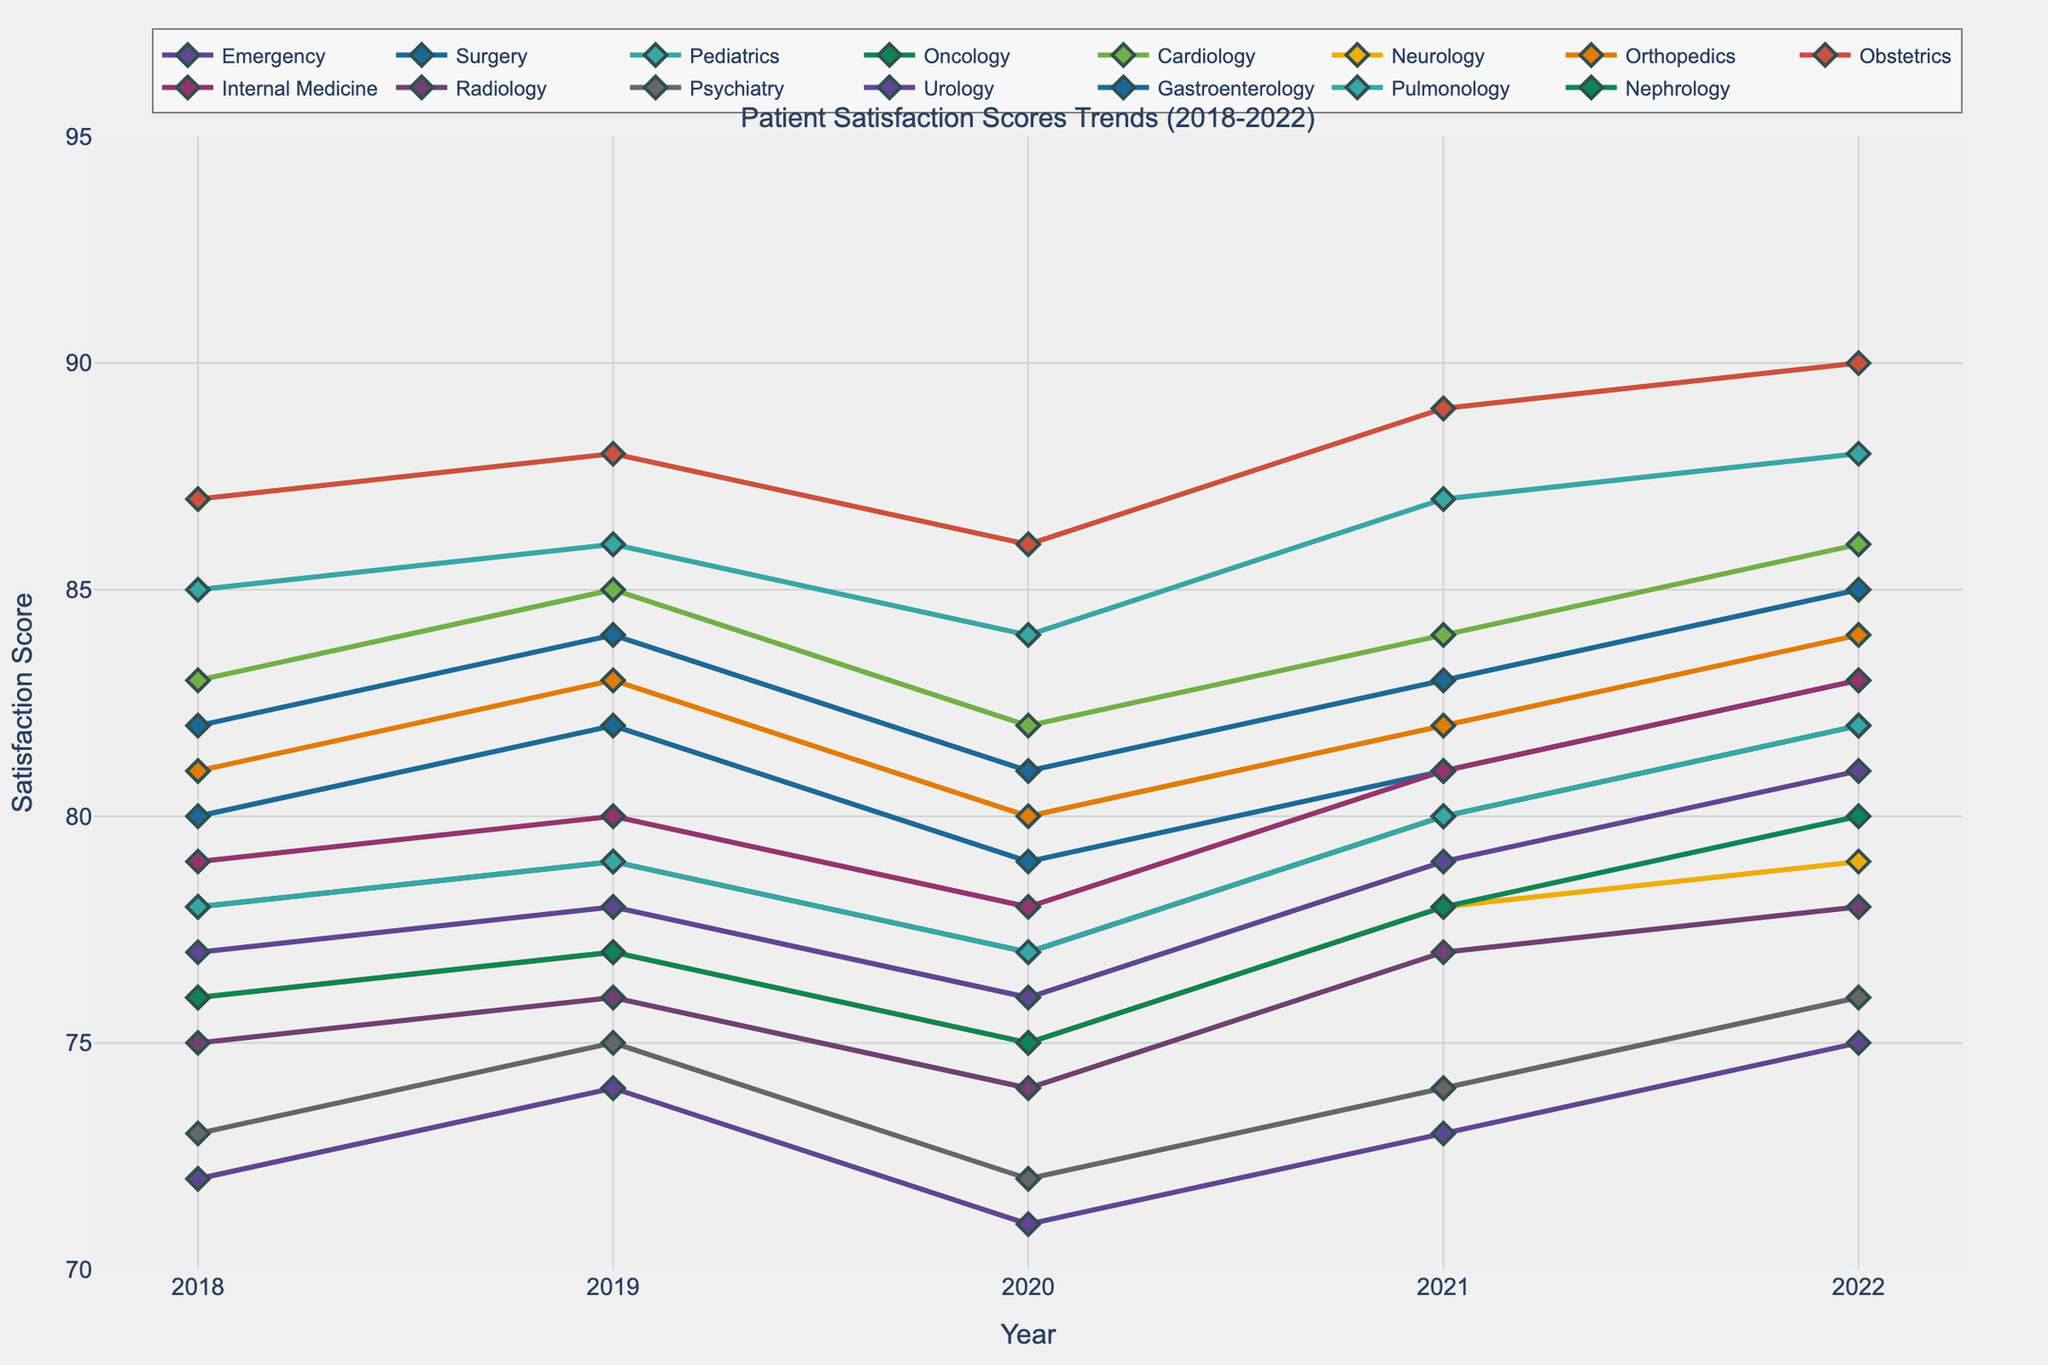what is the average satisfaction score for the Obstetrics department over the 5 years? The scores for the Obstetrics department from 2018 to 2022 are 87, 88, 86, 89, and 90. The sum of these scores is 87 + 88 + 86 + 89 + 90 = 440. Dividing by the number of years (5), the average score is 440 / 5 = 88
Answer: 88 Which department had the highest satisfaction score in 2022? Observing the plotted lines for all departments in 2022, the Obstetrics department has the highest score with 90.
Answer: Obstetrics Between Surgery and Oncology, which department showed a higher maximum satisfaction score over these five years? We need to compare the maximum scores of Surgery and Oncology. Surgery scores: 80, 82, 79, 81, 83; Oncology scores: 78, 79, 77, 80, 82. The maximum for Surgery is 83, and for Oncology, it is 82. Therefore, Surgery has the higher maximum.
Answer: Surgery How many departments had their highest satisfaction score in 2022? We need to check the lines for all departments to identify how many achieved their maximum scores in 2022. Those include Emergency, Surgery, Pediatrics, Oncology, Cardiology, Neurology, Orthopedics, Obstetrics, Internal Medicine, Radiology, Psychiatry, Urology, Gastroenterology, Pulmonology, and Nephrology. Counting them, we have 15 departments.
Answer: 15 Which department experienced the largest increase in satisfaction score from 2021 to 2022? To find this, we calculate the increase for each department between 2021 and 2022. The largest increase is observed in the Pediatrics department which increased from 87 to 88.
Answer: Pediatrics What is the range of satisfaction scores for the Cardiology department over the 5 years? The scores for Cardiology from 2018 to 2022 are 83, 85, 82, 84, and 86. The range is the difference between the maximum and minimum scores which is 86 - 82 = 4.
Answer: 4 